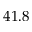<formula> <loc_0><loc_0><loc_500><loc_500>4 1 . 8</formula> 